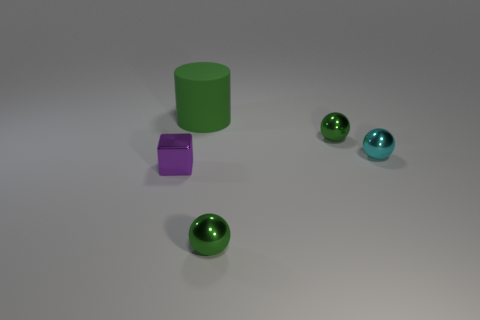Are there more tiny metal objects that are behind the green matte cylinder than large green cylinders?
Provide a succinct answer. No. There is a green rubber thing; is it the same shape as the small green thing behind the tiny block?
Keep it short and to the point. No. Is there anything else that has the same size as the green rubber thing?
Your answer should be compact. No. Is the number of tiny metallic blocks greater than the number of purple shiny spheres?
Provide a short and direct response. Yes. Does the big thing have the same shape as the small cyan metal object?
Provide a short and direct response. No. What material is the small sphere on the right side of the tiny green shiny thing that is behind the cyan ball?
Ensure brevity in your answer.  Metal. Do the purple cube and the cyan sphere have the same size?
Your answer should be compact. Yes. Are there any tiny cyan balls that are in front of the small object on the left side of the big green matte cylinder?
Provide a short and direct response. No. What shape is the object that is in front of the small purple object?
Provide a short and direct response. Sphere. What number of shiny objects are to the left of the small object in front of the small metal thing that is on the left side of the big matte cylinder?
Give a very brief answer. 1. 